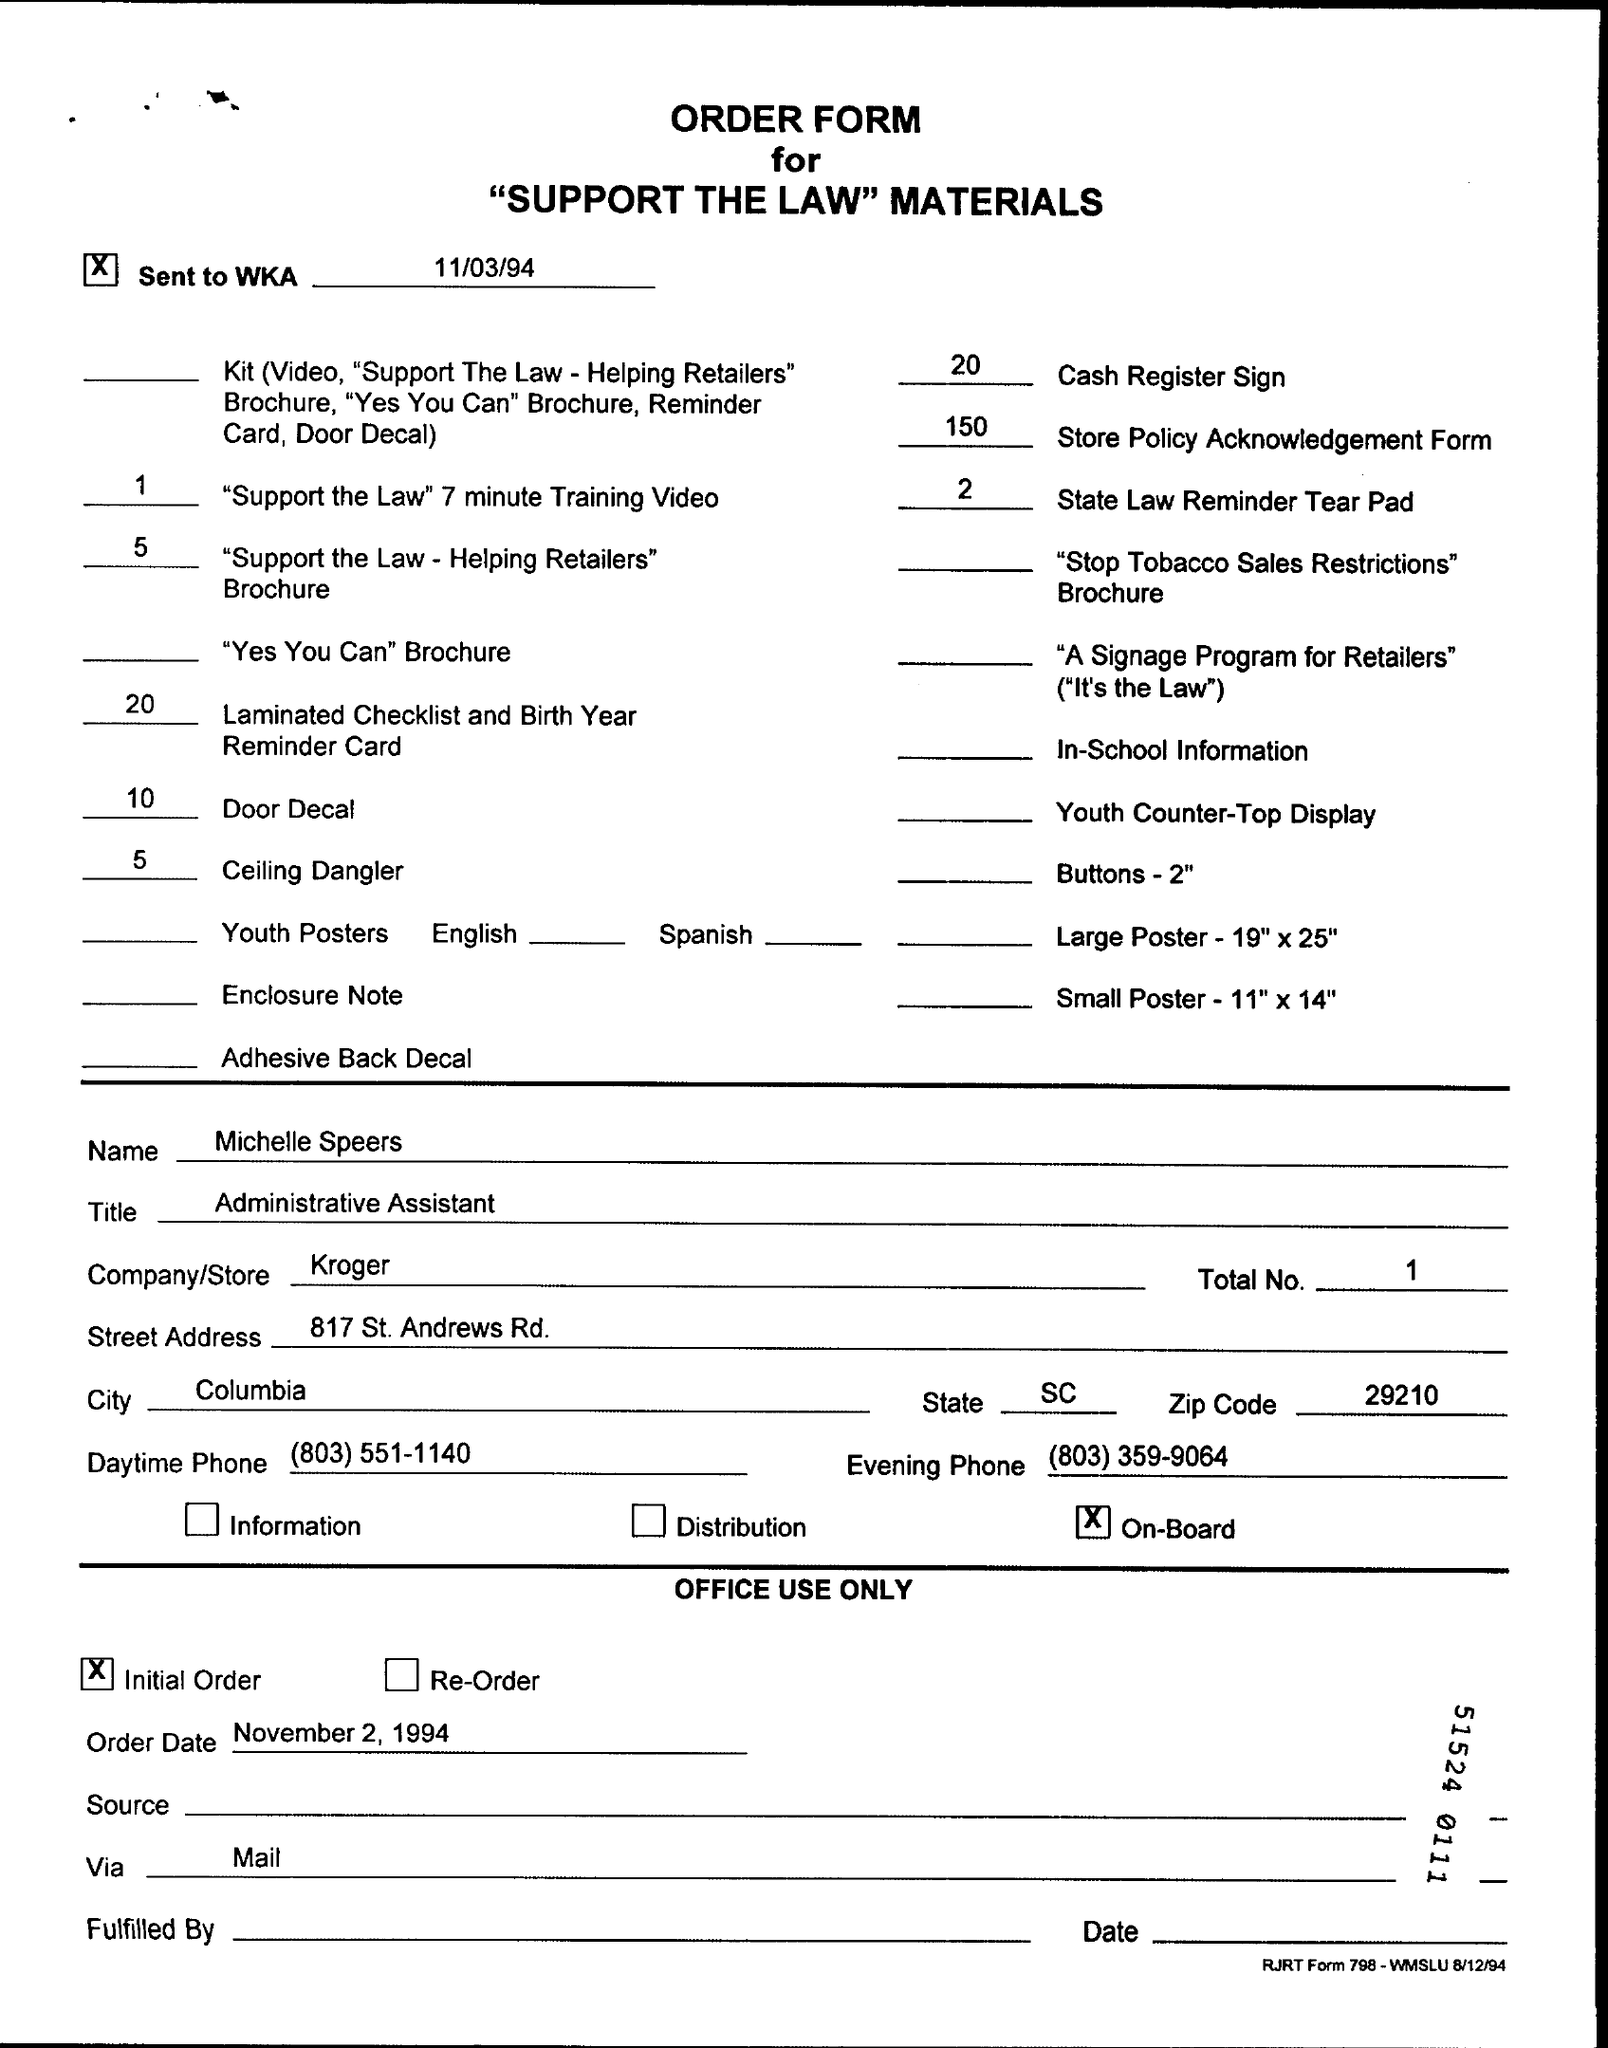Identify some key points in this picture. The zip code located in the page is 29210. The order date is November 2, 1994. 